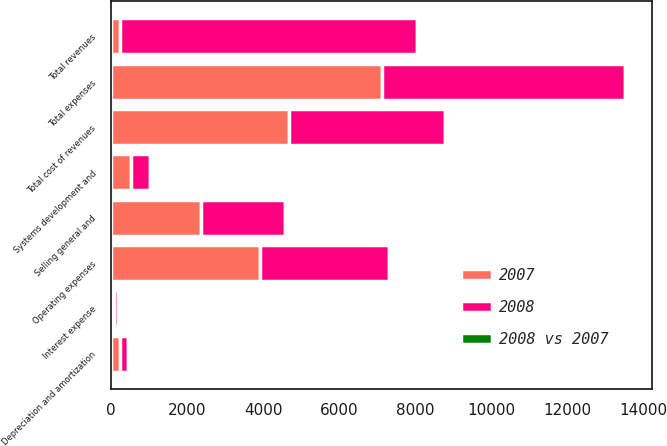Convert chart to OTSL. <chart><loc_0><loc_0><loc_500><loc_500><stacked_bar_chart><ecel><fcel>Total revenues<fcel>Operating expenses<fcel>Systems development and<fcel>Depreciation and amortization<fcel>Total cost of revenues<fcel>Selling general and<fcel>Interest expense<fcel>Total expenses<nl><fcel>2007<fcel>238.5<fcel>3915.7<fcel>525.9<fcel>238.5<fcel>4680.1<fcel>2370.4<fcel>80.5<fcel>7131<nl><fcel>2008<fcel>7800<fcel>3392.3<fcel>486.1<fcel>208.9<fcel>4087.3<fcel>2206.2<fcel>94.9<fcel>6388.4<nl><fcel>2008 vs 2007<fcel>13<fcel>15<fcel>8<fcel>14<fcel>15<fcel>7<fcel>15<fcel>12<nl></chart> 